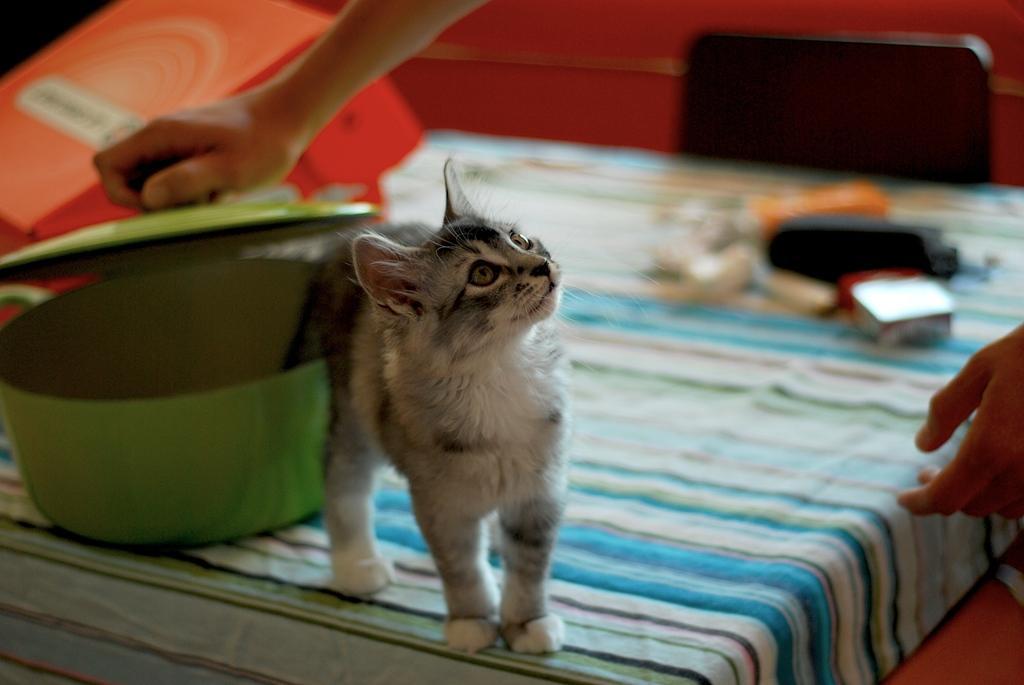How would you summarize this image in a sentence or two? On the left side, there is a cat standing on a table which is covered with a cloth on which, there is a green color vessel and other objects. Above this vessel, there is a person of a hand, holding a cup of this vessel. On the right side, there is a hand of a person. In the background, there is a black chair. And the background is blurred. 